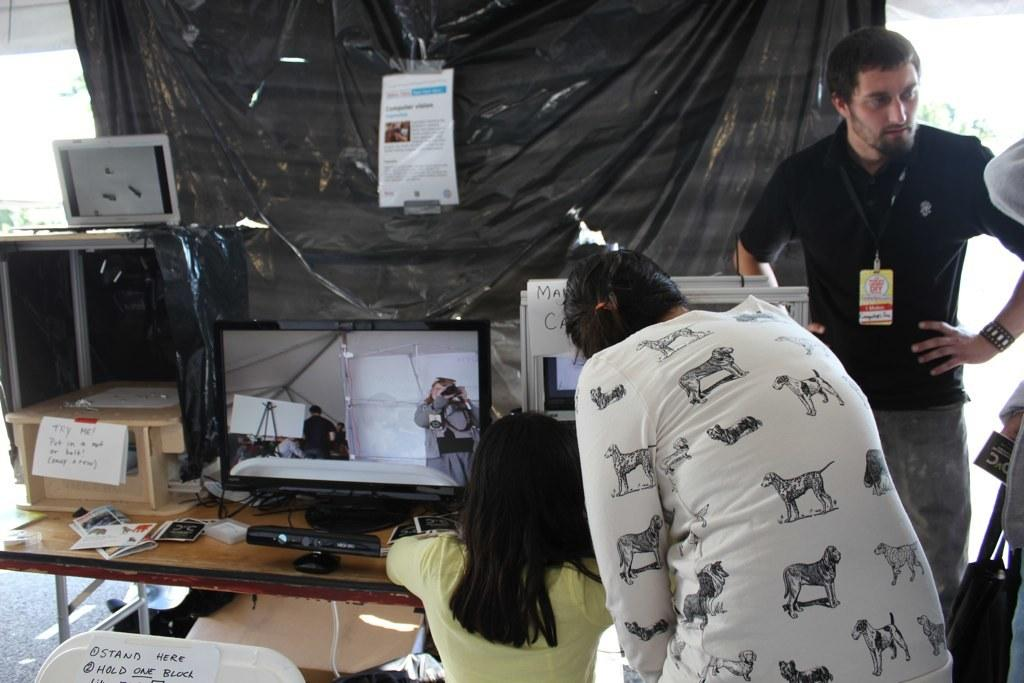What is the main object in the image? There is a table in the image. What can be seen on the table? There are many things on the table. Are there any people in the image? Yes, there are people standing near the table. What type of soap is being used by the people in the image? There is no soap present in the image; it features a table with many things on it and people standing near it. What is the destination of the journey depicted in the image? There is no journey depicted in the image; it only shows a table with many things on it and people standing near it. 